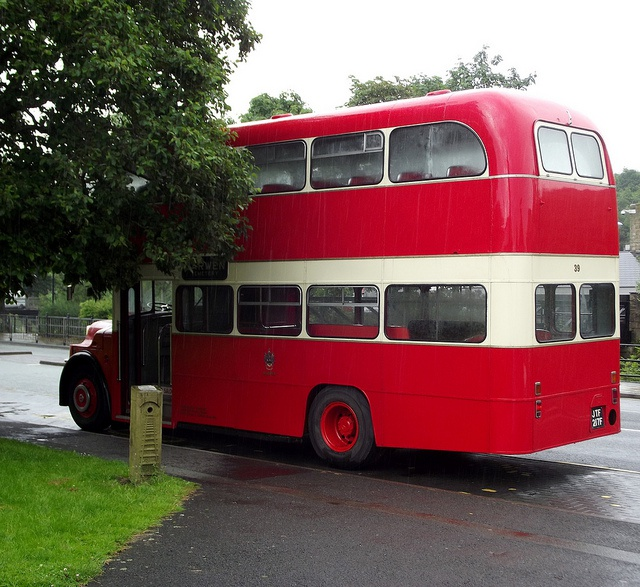Describe the objects in this image and their specific colors. I can see bus in darkgreen, brown, black, and ivory tones in this image. 